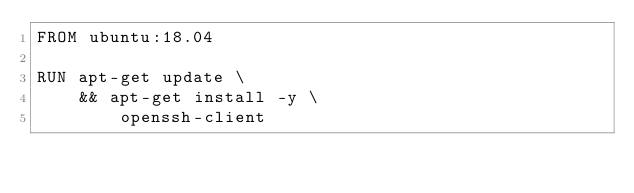Convert code to text. <code><loc_0><loc_0><loc_500><loc_500><_Dockerfile_>FROM ubuntu:18.04

RUN apt-get update \
    && apt-get install -y \
        openssh-client

</code> 